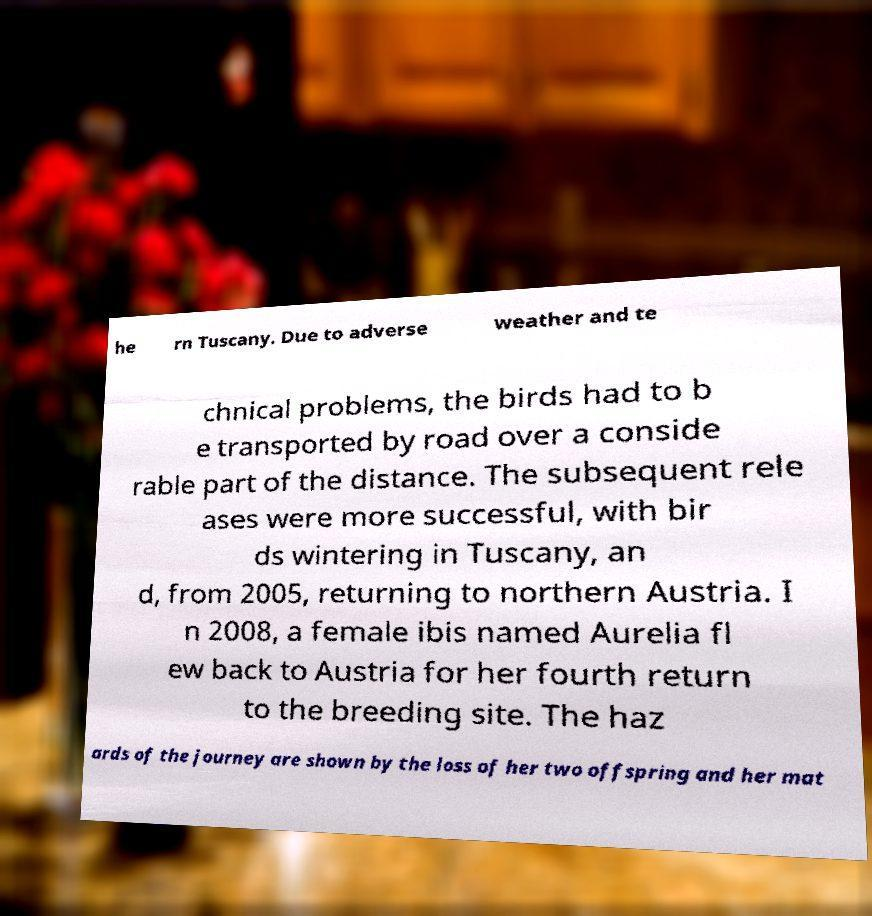I need the written content from this picture converted into text. Can you do that? he rn Tuscany. Due to adverse weather and te chnical problems, the birds had to b e transported by road over a conside rable part of the distance. The subsequent rele ases were more successful, with bir ds wintering in Tuscany, an d, from 2005, returning to northern Austria. I n 2008, a female ibis named Aurelia fl ew back to Austria for her fourth return to the breeding site. The haz ards of the journey are shown by the loss of her two offspring and her mat 